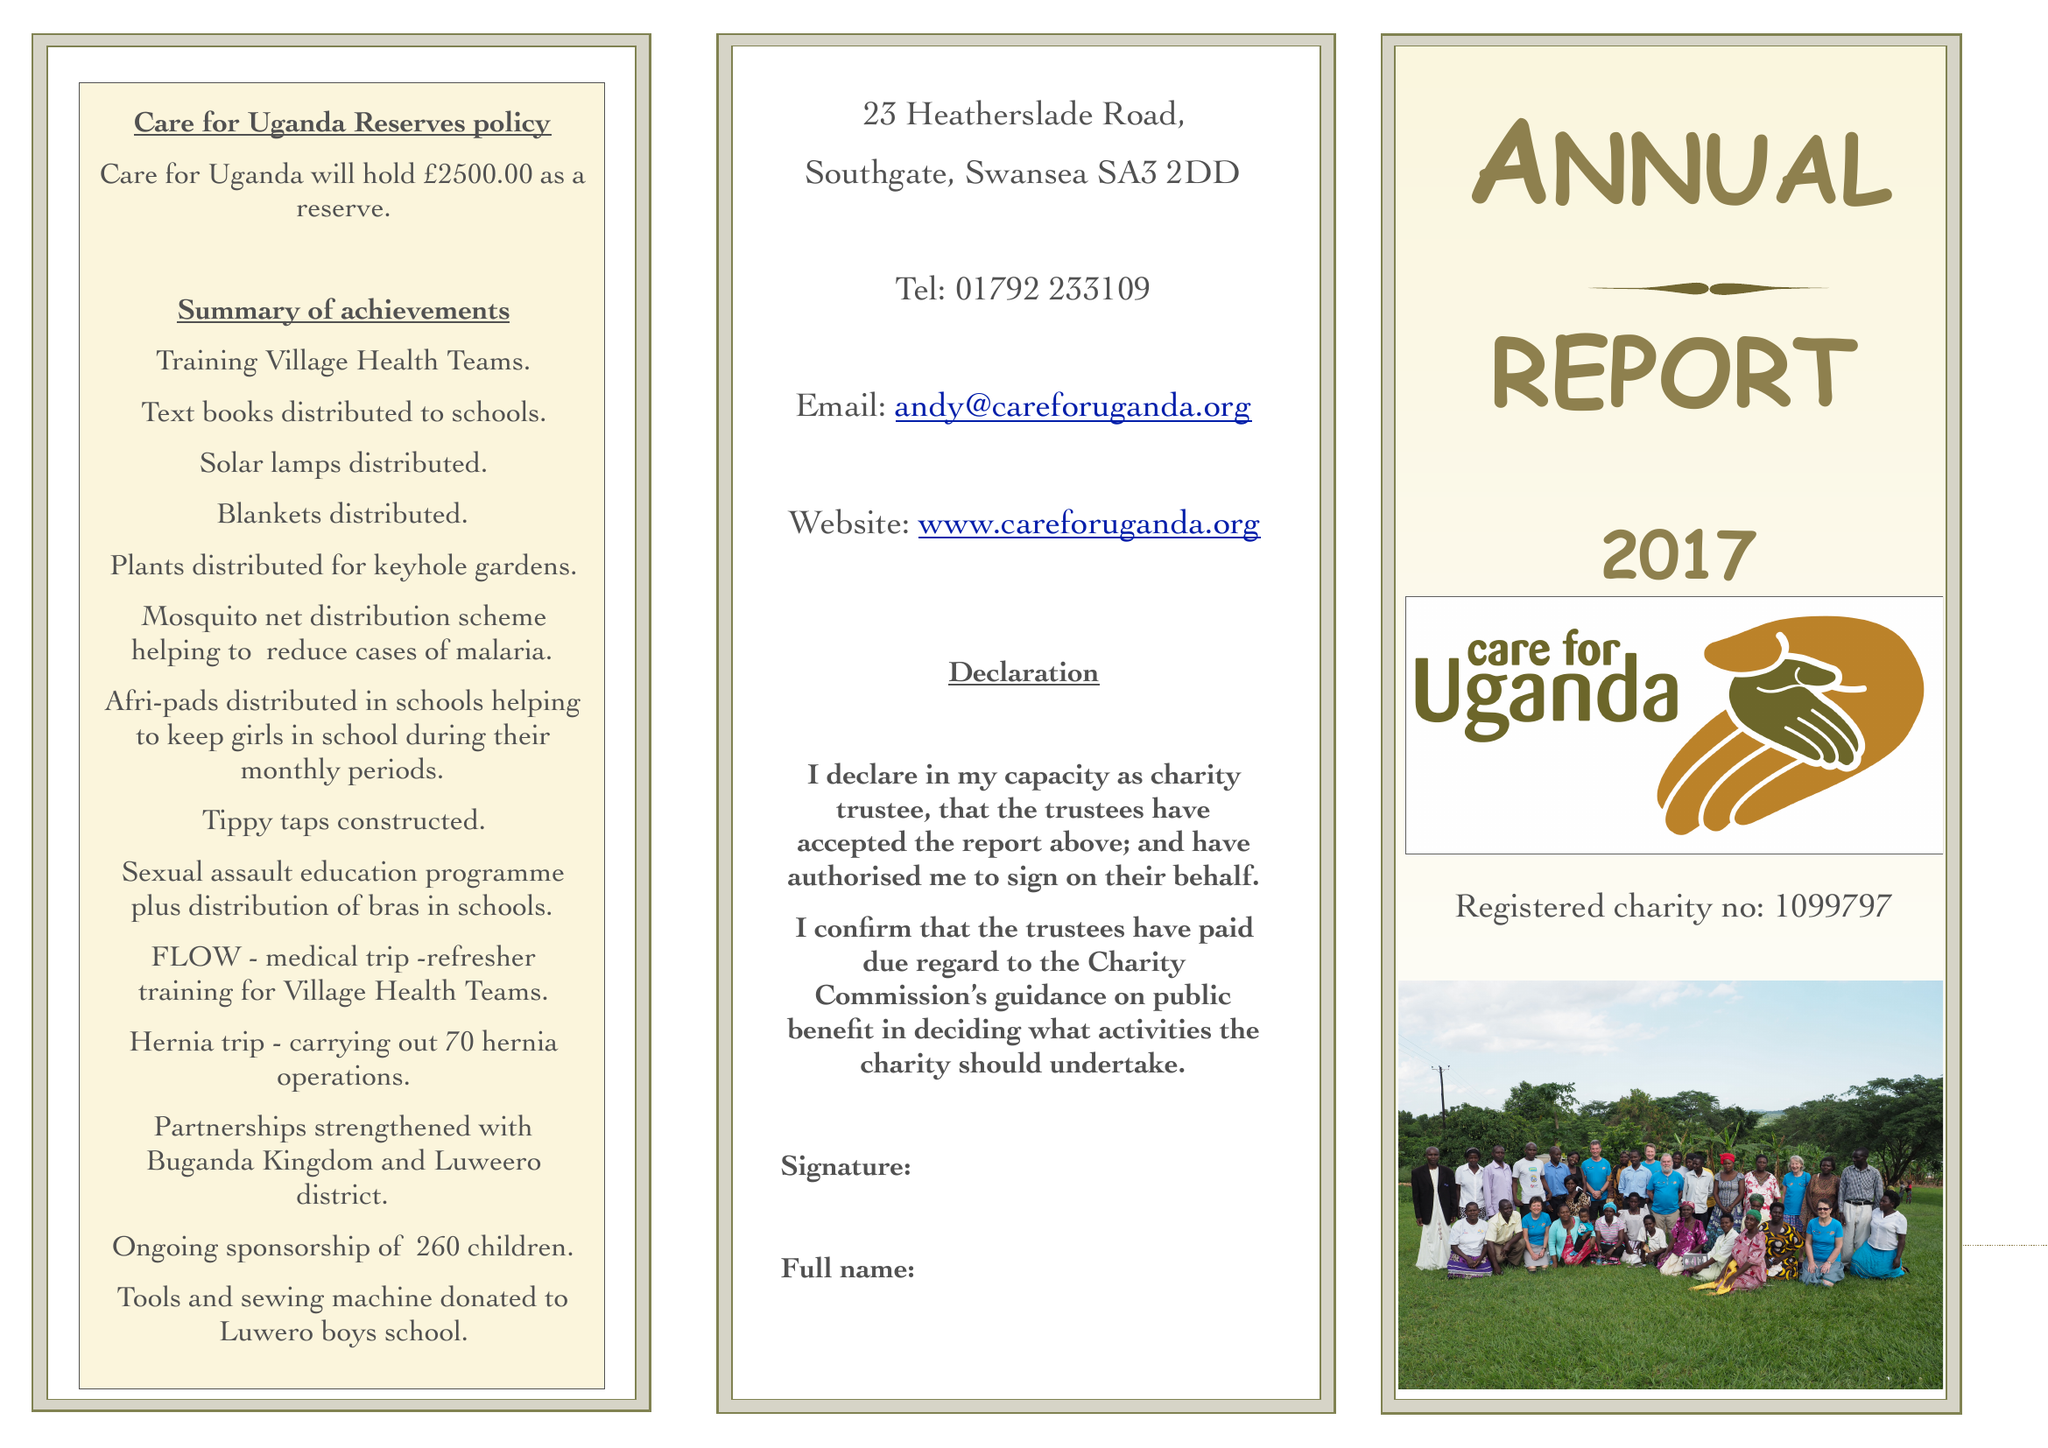What is the value for the report_date?
Answer the question using a single word or phrase. 2017-03-31 